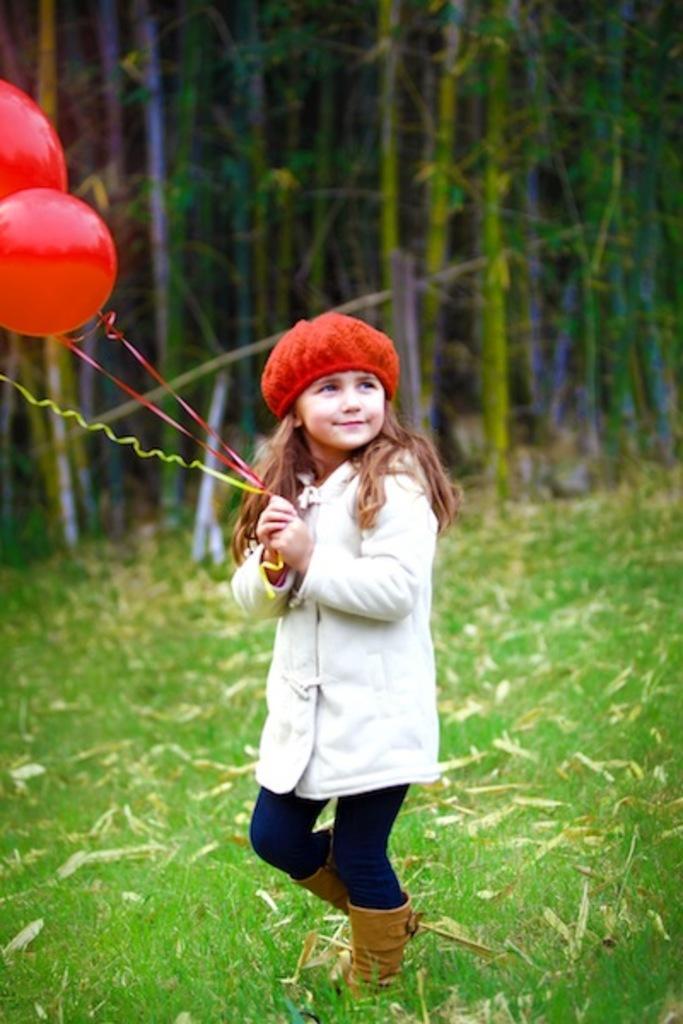Please provide a concise description of this image. In this picture I can see there is a girl standing here and smiling, she is wearing a coat and a red color cap. She is holding balloons. In the backdrop I can see there are few trees. 